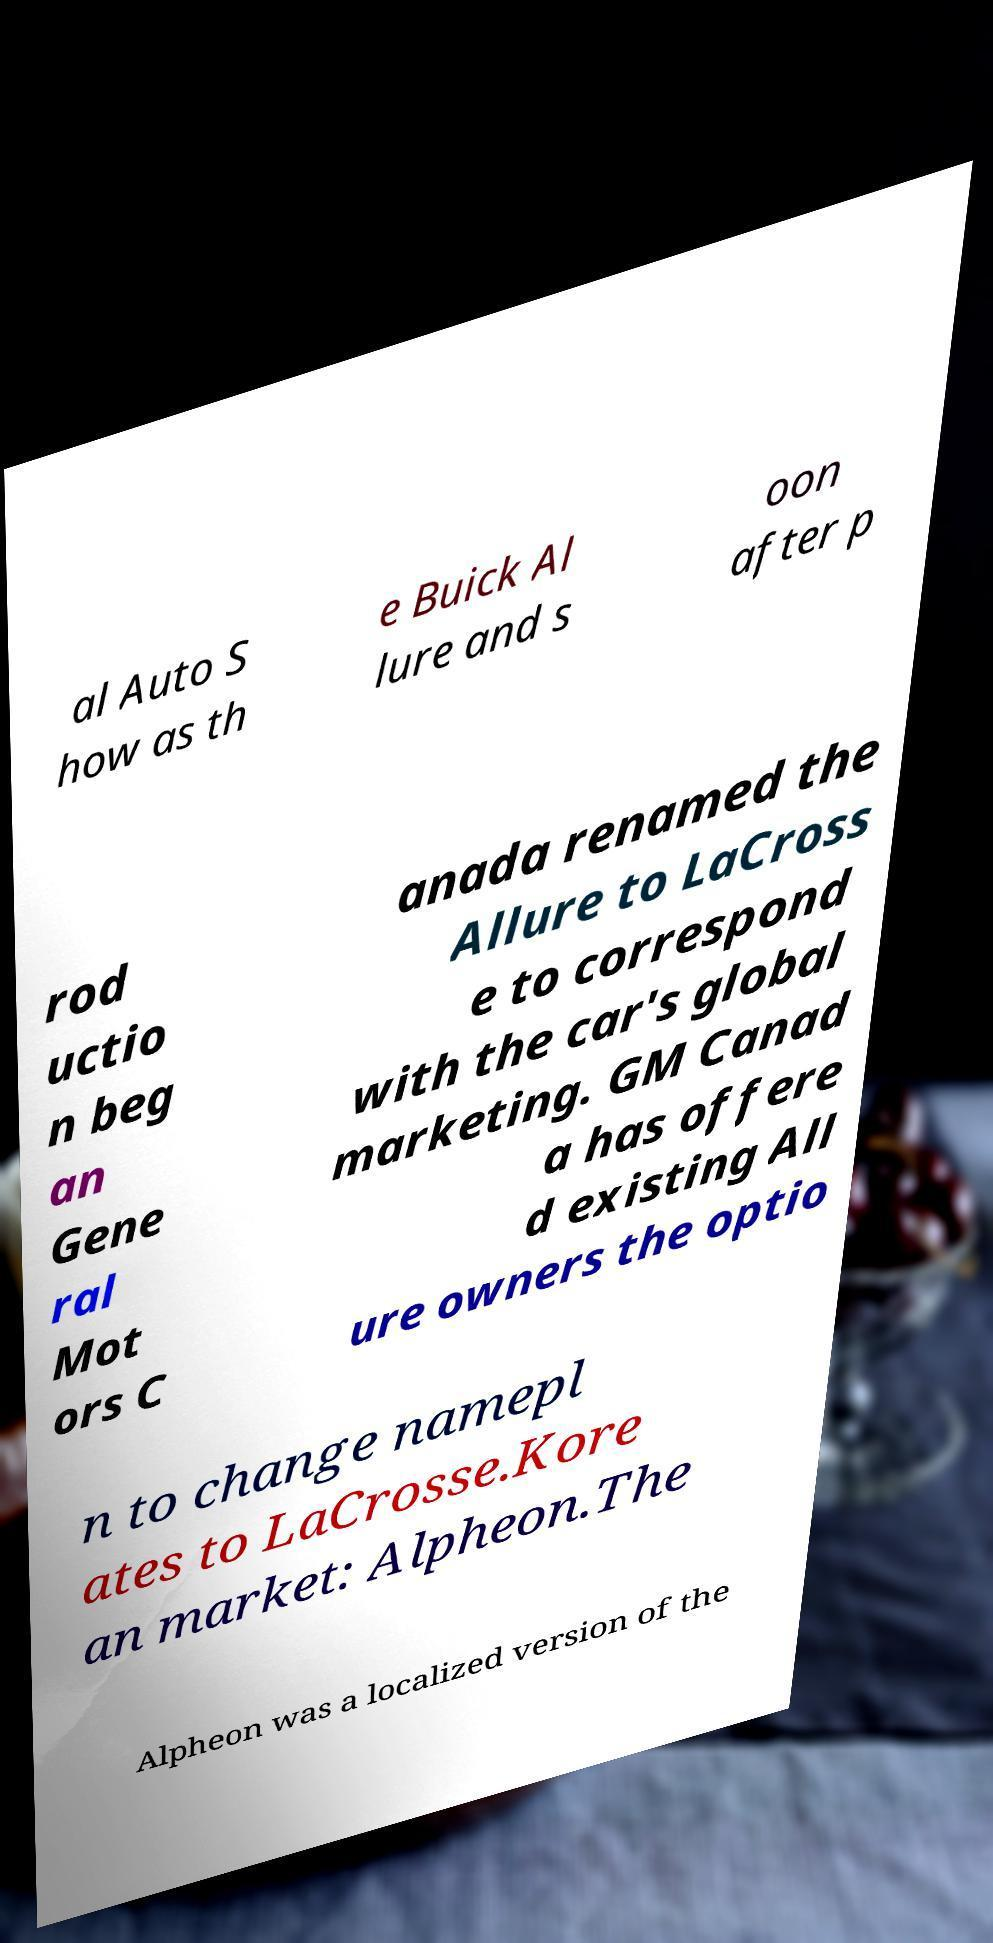What messages or text are displayed in this image? I need them in a readable, typed format. al Auto S how as th e Buick Al lure and s oon after p rod uctio n beg an Gene ral Mot ors C anada renamed the Allure to LaCross e to correspond with the car's global marketing. GM Canad a has offere d existing All ure owners the optio n to change namepl ates to LaCrosse.Kore an market: Alpheon.The Alpheon was a localized version of the 